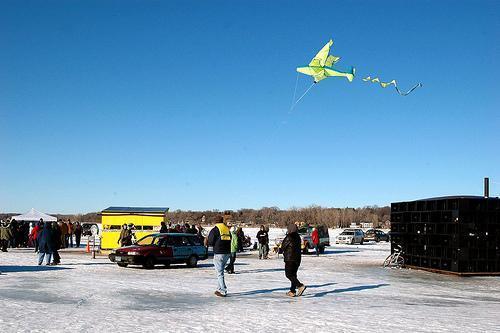How many kites are there?
Give a very brief answer. 1. How many bicycles are leaning against the black building?
Give a very brief answer. 1. 